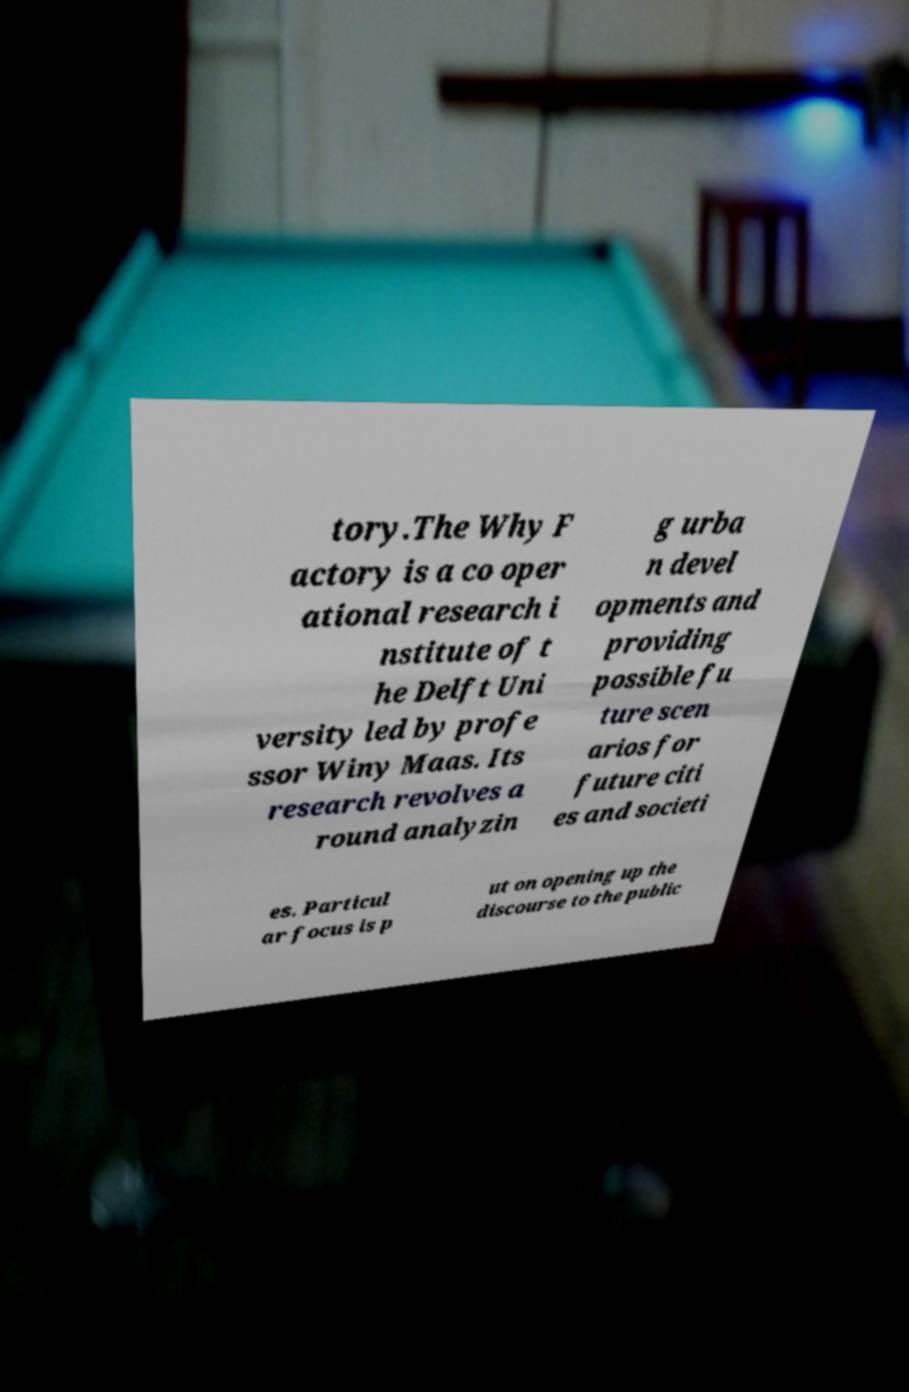For documentation purposes, I need the text within this image transcribed. Could you provide that? tory.The Why F actory is a co oper ational research i nstitute of t he Delft Uni versity led by profe ssor Winy Maas. Its research revolves a round analyzin g urba n devel opments and providing possible fu ture scen arios for future citi es and societi es. Particul ar focus is p ut on opening up the discourse to the public 